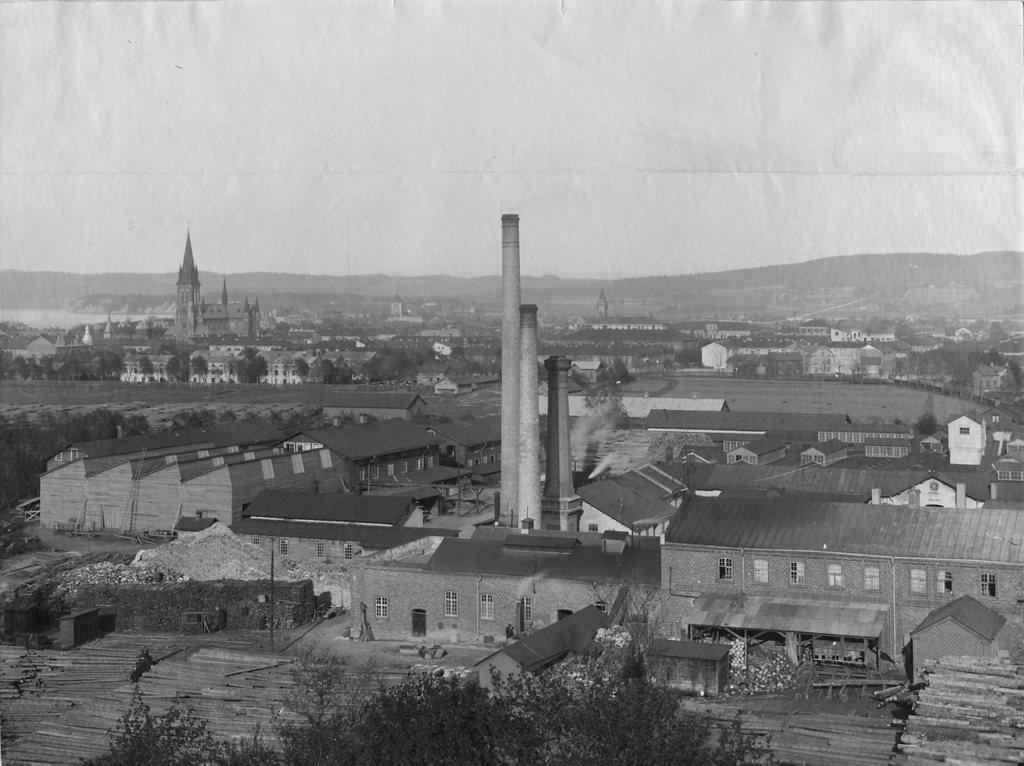Could you give a brief overview of what you see in this image? This is a black and white picture in which we can see a group of buildings with windows, towers, plants, trees, some wooden poles, the hills and the sky. 